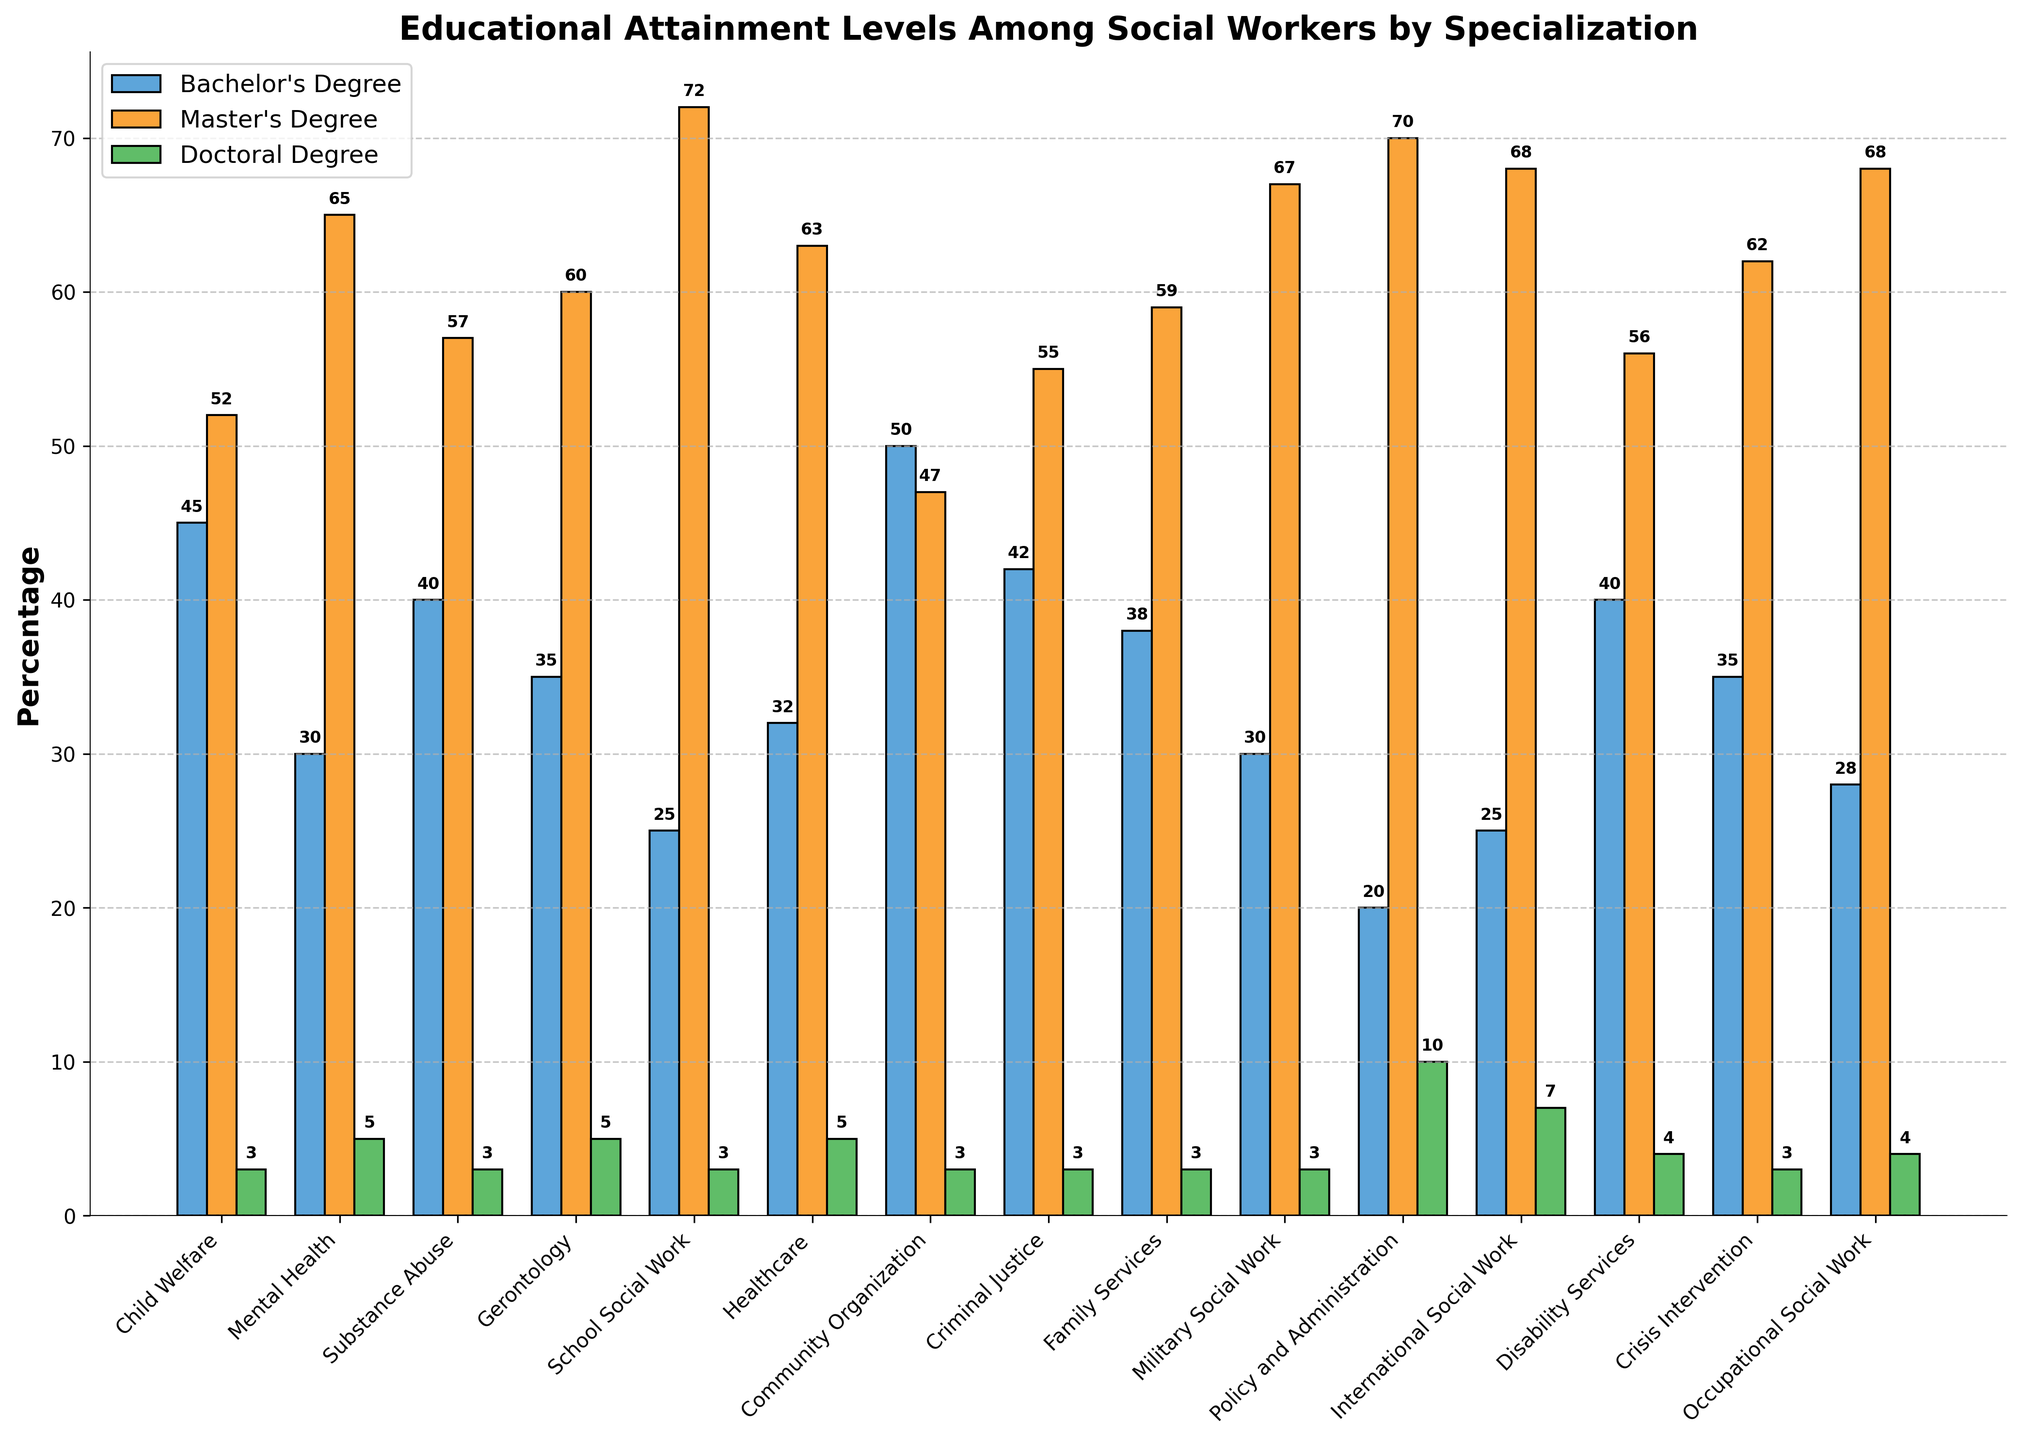Which specialization has the highest percentage of social workers with a Master's Degree? Look at each specialization and compare the heights of the orange bars representing the percentage of social workers with a Master's Degree. Identify the tallest bar.
Answer: School Social Work What is the total percentage of social workers with a Bachelor's Degree in Child Welfare and Gerontology? Sum the percentages of social workers with a Bachelor's Degree in Child Welfare (45%) and Gerontology (35%).
Answer: 80% Which specialization has more social workers with a Doctoral Degree, Policy and Administration or International Social Work? Compare the heights of the green bars for Policy and Administration and International Social Work, representing the percentage of social workers with Doctoral Degrees.
Answer: Policy and Administration Among the specializations listed, how many have a higher percentage of social workers with a Master's Degree than Bachelor's Degree? Count the number of orange bars that are taller than the corresponding blue bars.
Answer: 13 What is the average percentage of social workers with a Doctoral Degree across all specializations? Sum the percentages of social workers with Doctoral Degrees for all specializations and divide by the number of specializations. Calculation: (3+5+3+5+3+5+3+3+3+3+10+7+4+3+4) / 15 = 4
Answer: 4 In which specialization is the difference between the percentage of social workers with a Master's Degree and a Bachelor's Degree the greatest? For each specialization, subtract the percentage of Bachelor's Degree holders from Master's Degree holders and find the maximum difference. Calculation: (72-25)=47 for School Social Work
Answer: School Social Work Are there any specializations where the percentage of social workers with a Doctoral Degree is the same? If yes, name them. Look for specializations where the green bars (Doctoral Degree) are of the same height.
Answer: Child Welfare, Substance Abuse, Community Organization, Criminal Justice, Family Services, Military Social Work, Crisis Intervention How does the percentage of social workers with a Master's Degree in Mental Health compare to those in Military Social Work? Compare the heights of the orange bars representing Mental Health and Military Social Work to see which one is taller.
Answer: Military Social Work is higher What is the combined percentage of social workers with a Bachelor's and Master's Degree in Disability Services? Add the percentages of social workers with Bachelor's (40%) and Master's Degrees (56%) in Disability Services.
Answer: 96% 